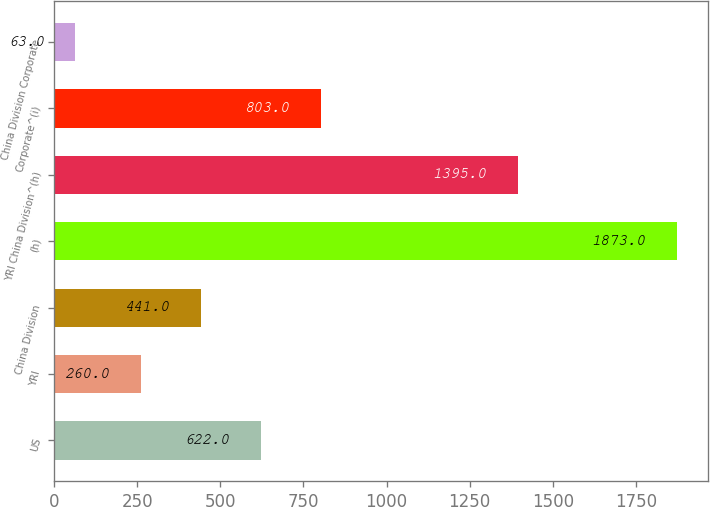Convert chart. <chart><loc_0><loc_0><loc_500><loc_500><bar_chart><fcel>US<fcel>YRI<fcel>China Division<fcel>(h)<fcel>YRI China Division^(h)<fcel>Corporate^(i)<fcel>China Division Corporate<nl><fcel>622<fcel>260<fcel>441<fcel>1873<fcel>1395<fcel>803<fcel>63<nl></chart> 